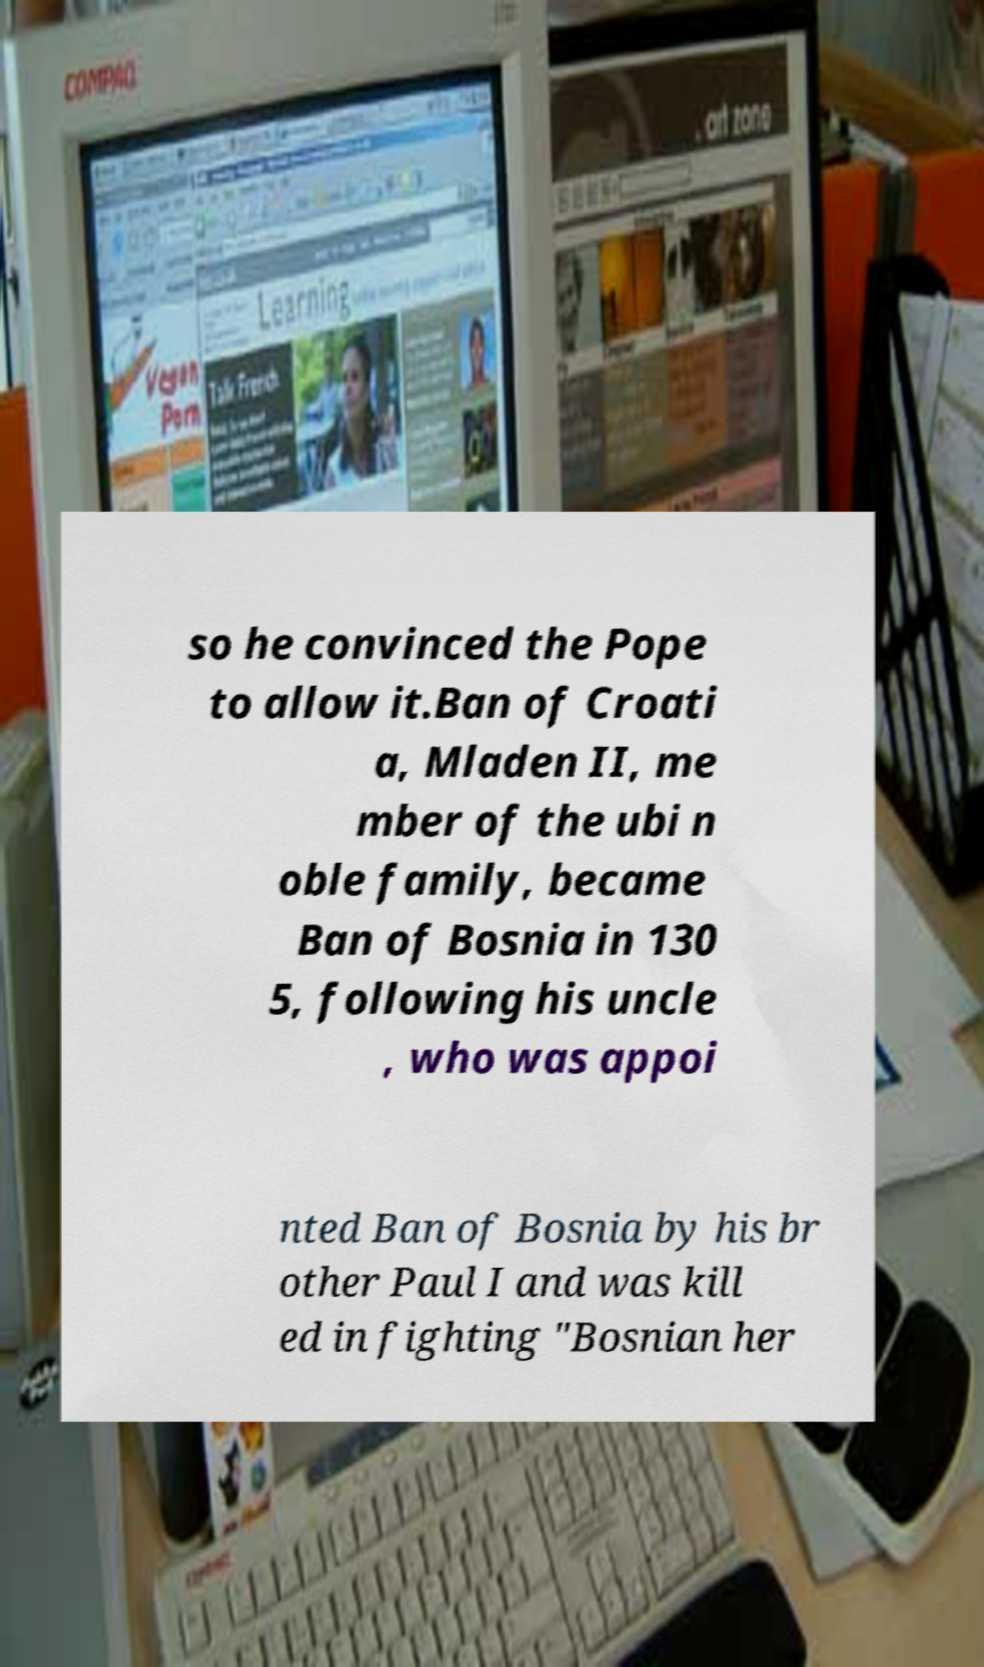What messages or text are displayed in this image? I need them in a readable, typed format. so he convinced the Pope to allow it.Ban of Croati a, Mladen II, me mber of the ubi n oble family, became Ban of Bosnia in 130 5, following his uncle , who was appoi nted Ban of Bosnia by his br other Paul I and was kill ed in fighting "Bosnian her 